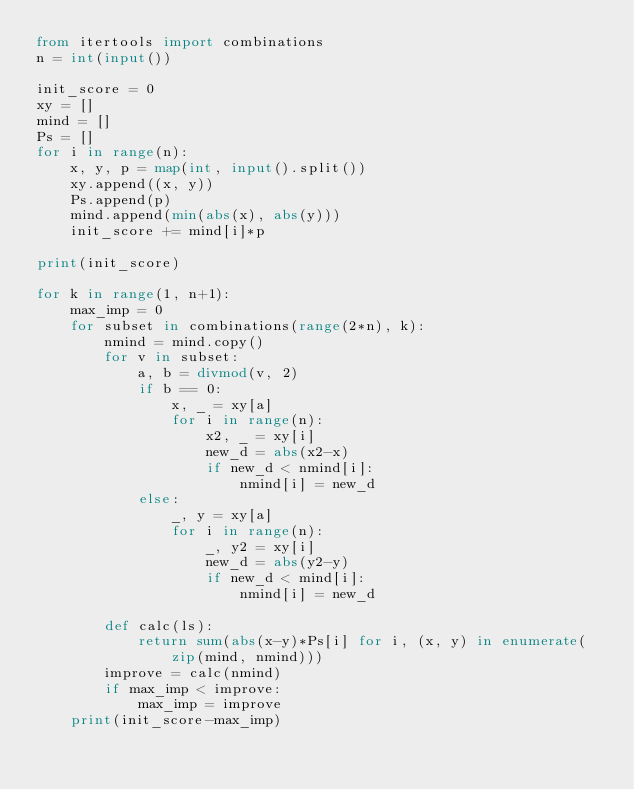Convert code to text. <code><loc_0><loc_0><loc_500><loc_500><_Python_>from itertools import combinations
n = int(input())

init_score = 0
xy = []
mind = []
Ps = []
for i in range(n):
    x, y, p = map(int, input().split())
    xy.append((x, y))
    Ps.append(p)
    mind.append(min(abs(x), abs(y)))
    init_score += mind[i]*p

print(init_score)

for k in range(1, n+1):
    max_imp = 0
    for subset in combinations(range(2*n), k):
        nmind = mind.copy()
        for v in subset:
            a, b = divmod(v, 2)
            if b == 0:
                x, _ = xy[a]
                for i in range(n):
                    x2, _ = xy[i]
                    new_d = abs(x2-x)
                    if new_d < nmind[i]:
                        nmind[i] = new_d
            else:
                _, y = xy[a]
                for i in range(n):
                    _, y2 = xy[i]
                    new_d = abs(y2-y)
                    if new_d < mind[i]:
                        nmind[i] = new_d

        def calc(ls):
            return sum(abs(x-y)*Ps[i] for i, (x, y) in enumerate(zip(mind, nmind)))
        improve = calc(nmind)
        if max_imp < improve:
            max_imp = improve
    print(init_score-max_imp)
</code> 